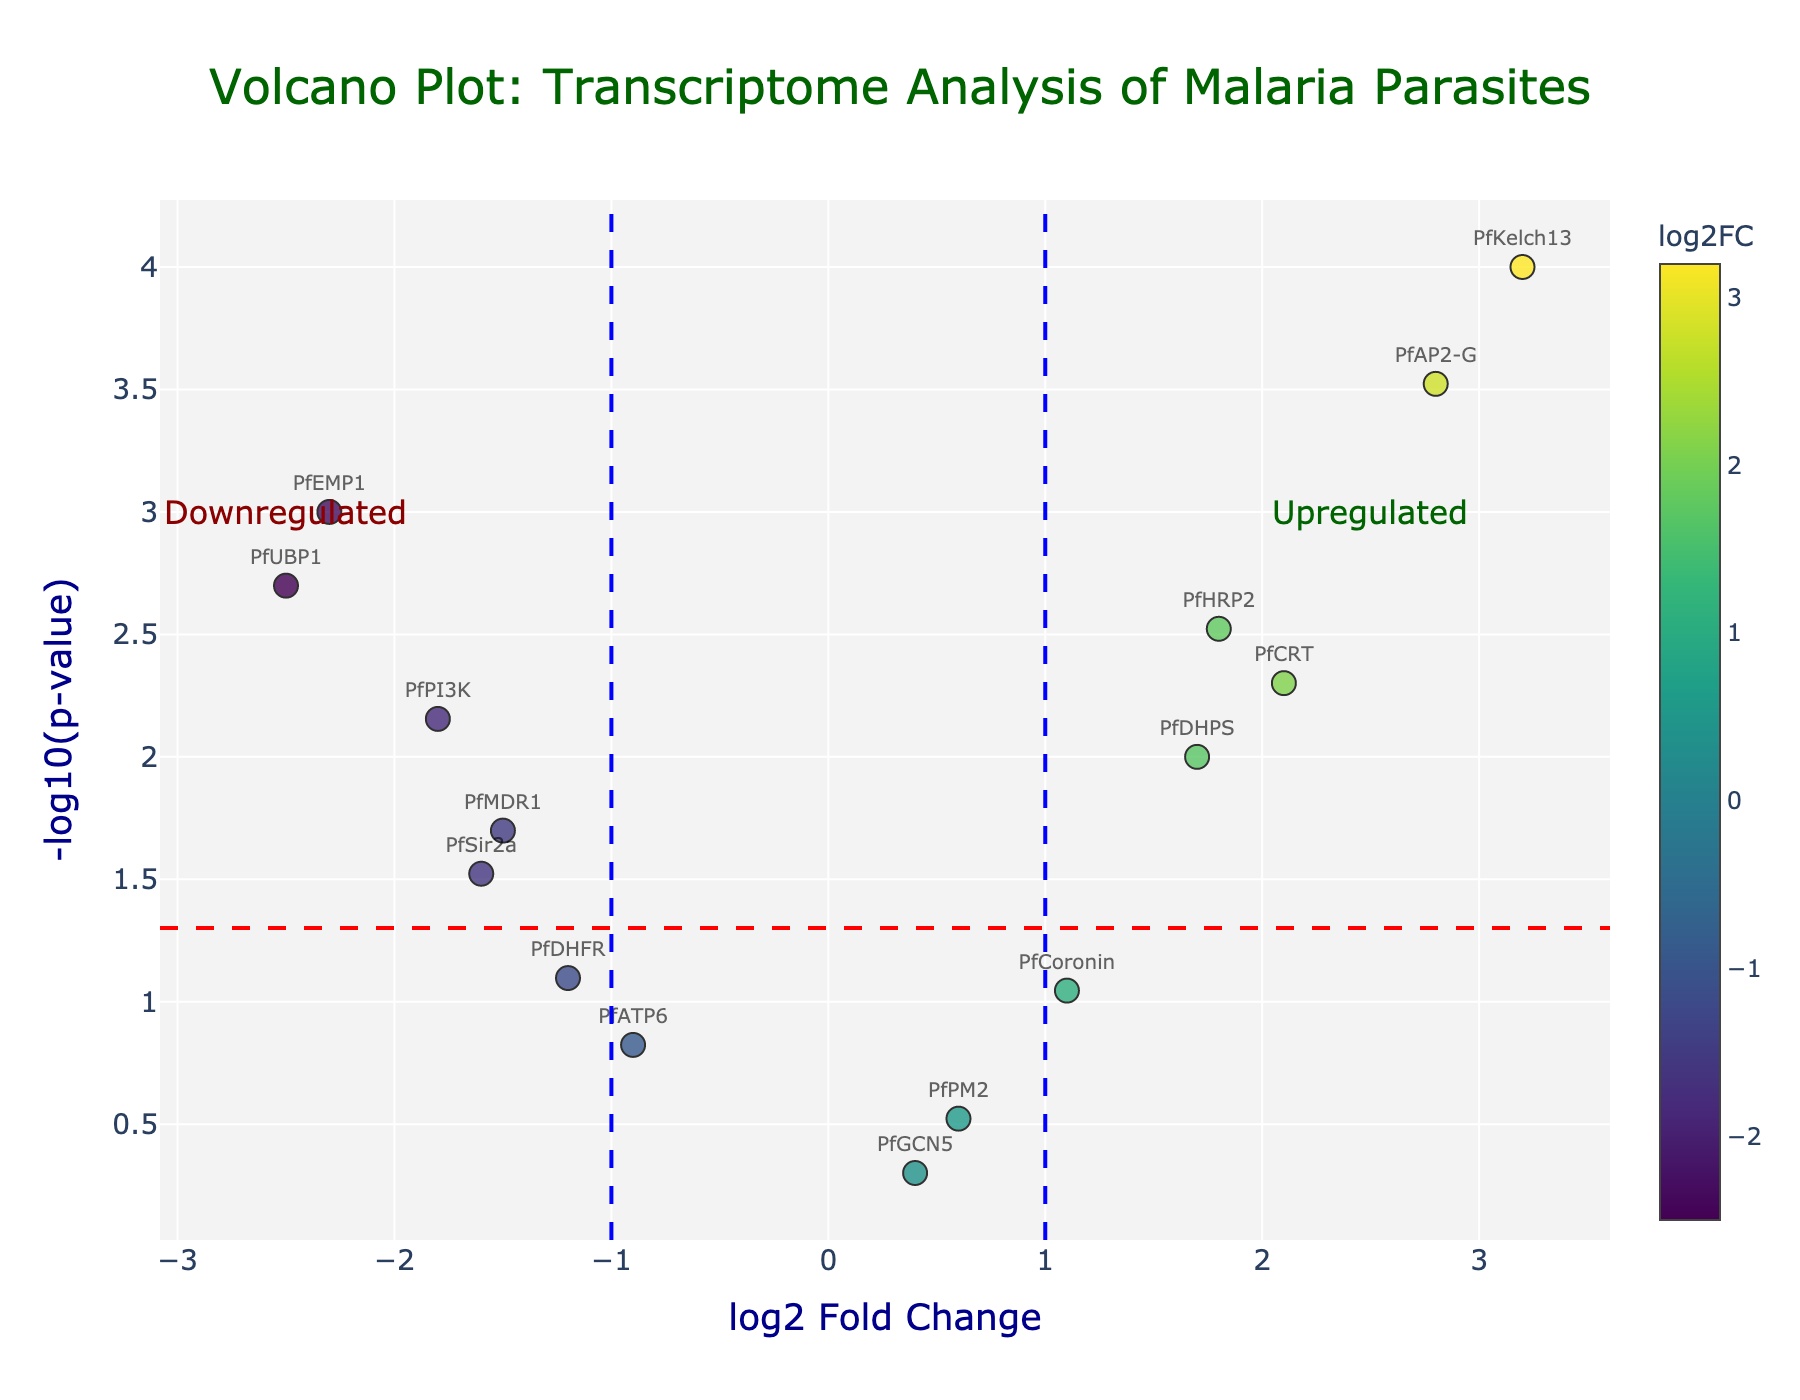How many genes had significant changes in expression with a p-value less than 0.05? Look for data points with a -log10(p-value) greater than -log10(0.05). There are 11 genes meeting this criterion.
Answer: 11 Which gene is the most upregulated in response to the antimalarial herbs? The most upregulated gene will have the highest positive log2FoldChange. From the plot, PfKelch13 has the highest log2FoldChange of 3.2.
Answer: PfKelch13 Which gene has the most significant p-value? The most significant p-value corresponds to the highest -log10(p-value) in the plot. This gene is PfKelch13 with -log10(p-value) of 4.
Answer: PfKelch13 How many genes are significantly downregulated? To be significantly downregulated, genes should have a log2FoldChange < -1 and a p-value < 0.05. There are 5 such genes: PfEMP1, PfMDR1, PfUBP1, PfPI3K, and PfSir2a.
Answer: 5 What genes are on the threshold lines for log2 fold change? Genes on threshold lines have a log2FoldChange of exactly ±1. PfCoronin has a log2FoldChange of ~1.1 and PfDHFR has a log2FoldChange of -1.2.
Answer: PfCoronin, PfDHFR What is the range of log2 fold change values for the presented genes? The range is found by subtracting the smallest log2FoldChange value from the largest. The values range from -2.5 (PfUBP1) to 3.2 (PfKelch13), so the range is 5.7.
Answer: 5.7 Which gene has a log2 fold change closest to zero and what is its value? The gene with the log2FoldChange closest to zero shows minimal change. This gene is PfGCN5 with a log2FoldChange of 0.4.
Answer: PfGCN5, 0.4 